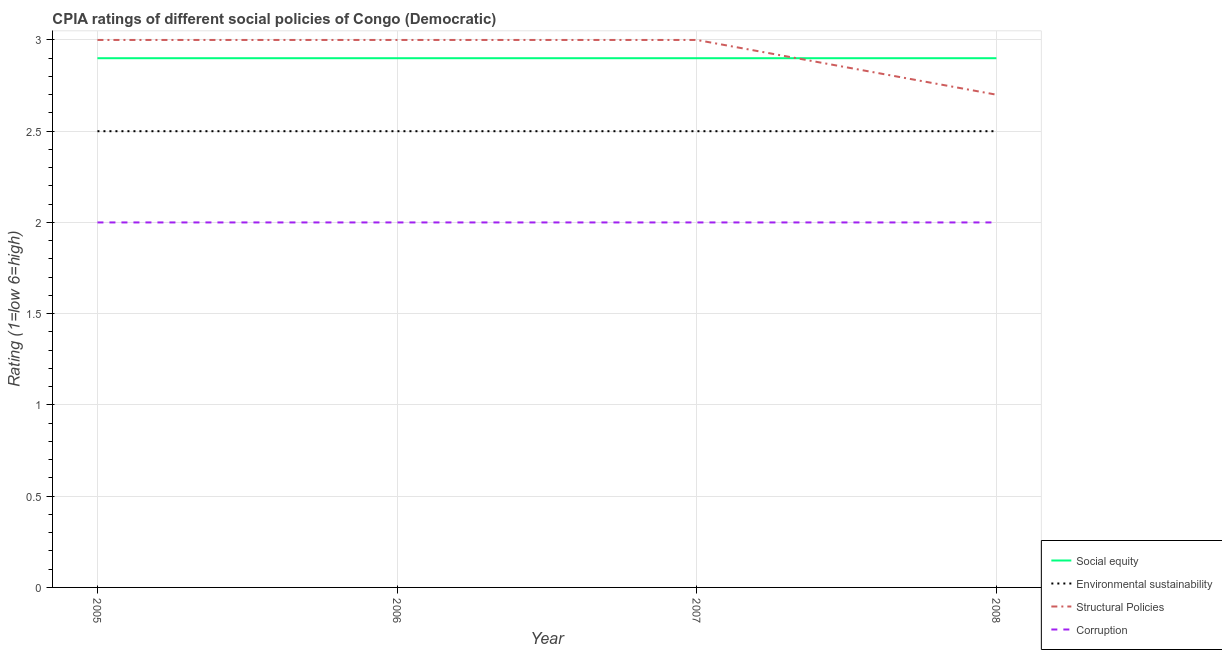What is the cpia rating of corruption in 2008?
Offer a terse response. 2. Across all years, what is the maximum cpia rating of corruption?
Your answer should be compact. 2. Across all years, what is the minimum cpia rating of environmental sustainability?
Provide a succinct answer. 2.5. What is the total cpia rating of social equity in the graph?
Offer a terse response. 11.6. What is the difference between the cpia rating of corruption in 2006 and that in 2007?
Make the answer very short. 0. What is the average cpia rating of structural policies per year?
Offer a very short reply. 2.92. In the year 2007, what is the difference between the cpia rating of corruption and cpia rating of environmental sustainability?
Your answer should be very brief. -0.5. In how many years, is the cpia rating of social equity greater than 1.1?
Your answer should be very brief. 4. Is the cpia rating of corruption in 2005 less than that in 2006?
Keep it short and to the point. No. Is the difference between the cpia rating of environmental sustainability in 2006 and 2008 greater than the difference between the cpia rating of corruption in 2006 and 2008?
Give a very brief answer. No. What is the difference between the highest and the second highest cpia rating of environmental sustainability?
Provide a short and direct response. 0. Is it the case that in every year, the sum of the cpia rating of social equity and cpia rating of environmental sustainability is greater than the cpia rating of structural policies?
Offer a terse response. Yes. Is the cpia rating of structural policies strictly greater than the cpia rating of environmental sustainability over the years?
Your answer should be very brief. Yes. What is the difference between two consecutive major ticks on the Y-axis?
Keep it short and to the point. 0.5. Are the values on the major ticks of Y-axis written in scientific E-notation?
Give a very brief answer. No. Does the graph contain any zero values?
Offer a terse response. No. Does the graph contain grids?
Ensure brevity in your answer.  Yes. What is the title of the graph?
Provide a short and direct response. CPIA ratings of different social policies of Congo (Democratic). Does "Payroll services" appear as one of the legend labels in the graph?
Make the answer very short. No. What is the label or title of the X-axis?
Your answer should be compact. Year. What is the Rating (1=low 6=high) of Social equity in 2007?
Offer a terse response. 2.9. What is the Rating (1=low 6=high) in Environmental sustainability in 2007?
Offer a terse response. 2.5. What is the Rating (1=low 6=high) in Environmental sustainability in 2008?
Make the answer very short. 2.5. What is the Rating (1=low 6=high) of Structural Policies in 2008?
Keep it short and to the point. 2.7. What is the Rating (1=low 6=high) of Corruption in 2008?
Make the answer very short. 2. Across all years, what is the maximum Rating (1=low 6=high) in Social equity?
Provide a succinct answer. 2.9. Across all years, what is the maximum Rating (1=low 6=high) in Structural Policies?
Offer a terse response. 3. Across all years, what is the maximum Rating (1=low 6=high) in Corruption?
Your answer should be compact. 2. Across all years, what is the minimum Rating (1=low 6=high) in Corruption?
Your answer should be compact. 2. What is the total Rating (1=low 6=high) of Environmental sustainability in the graph?
Provide a short and direct response. 10. What is the total Rating (1=low 6=high) in Structural Policies in the graph?
Ensure brevity in your answer.  11.7. What is the total Rating (1=low 6=high) of Corruption in the graph?
Offer a very short reply. 8. What is the difference between the Rating (1=low 6=high) of Social equity in 2005 and that in 2006?
Ensure brevity in your answer.  0. What is the difference between the Rating (1=low 6=high) of Environmental sustainability in 2005 and that in 2006?
Provide a short and direct response. 0. What is the difference between the Rating (1=low 6=high) of Structural Policies in 2005 and that in 2006?
Your response must be concise. 0. What is the difference between the Rating (1=low 6=high) in Social equity in 2005 and that in 2007?
Offer a terse response. 0. What is the difference between the Rating (1=low 6=high) of Structural Policies in 2005 and that in 2007?
Keep it short and to the point. 0. What is the difference between the Rating (1=low 6=high) of Corruption in 2005 and that in 2007?
Offer a very short reply. 0. What is the difference between the Rating (1=low 6=high) in Environmental sustainability in 2005 and that in 2008?
Ensure brevity in your answer.  0. What is the difference between the Rating (1=low 6=high) of Structural Policies in 2005 and that in 2008?
Ensure brevity in your answer.  0.3. What is the difference between the Rating (1=low 6=high) in Social equity in 2006 and that in 2007?
Ensure brevity in your answer.  0. What is the difference between the Rating (1=low 6=high) in Social equity in 2006 and that in 2008?
Provide a short and direct response. 0. What is the difference between the Rating (1=low 6=high) of Social equity in 2007 and that in 2008?
Provide a succinct answer. 0. What is the difference between the Rating (1=low 6=high) in Social equity in 2005 and the Rating (1=low 6=high) in Structural Policies in 2006?
Ensure brevity in your answer.  -0.1. What is the difference between the Rating (1=low 6=high) of Social equity in 2005 and the Rating (1=low 6=high) of Corruption in 2006?
Provide a succinct answer. 0.9. What is the difference between the Rating (1=low 6=high) in Structural Policies in 2005 and the Rating (1=low 6=high) in Corruption in 2006?
Provide a succinct answer. 1. What is the difference between the Rating (1=low 6=high) in Social equity in 2005 and the Rating (1=low 6=high) in Corruption in 2007?
Ensure brevity in your answer.  0.9. What is the difference between the Rating (1=low 6=high) in Environmental sustainability in 2005 and the Rating (1=low 6=high) in Structural Policies in 2007?
Offer a very short reply. -0.5. What is the difference between the Rating (1=low 6=high) of Environmental sustainability in 2005 and the Rating (1=low 6=high) of Corruption in 2007?
Ensure brevity in your answer.  0.5. What is the difference between the Rating (1=low 6=high) of Structural Policies in 2005 and the Rating (1=low 6=high) of Corruption in 2007?
Offer a terse response. 1. What is the difference between the Rating (1=low 6=high) of Social equity in 2005 and the Rating (1=low 6=high) of Structural Policies in 2008?
Your response must be concise. 0.2. What is the difference between the Rating (1=low 6=high) in Environmental sustainability in 2005 and the Rating (1=low 6=high) in Corruption in 2008?
Your answer should be very brief. 0.5. What is the difference between the Rating (1=low 6=high) in Structural Policies in 2005 and the Rating (1=low 6=high) in Corruption in 2008?
Keep it short and to the point. 1. What is the difference between the Rating (1=low 6=high) of Social equity in 2006 and the Rating (1=low 6=high) of Corruption in 2007?
Provide a succinct answer. 0.9. What is the difference between the Rating (1=low 6=high) in Environmental sustainability in 2006 and the Rating (1=low 6=high) in Structural Policies in 2007?
Your answer should be very brief. -0.5. What is the difference between the Rating (1=low 6=high) of Structural Policies in 2006 and the Rating (1=low 6=high) of Corruption in 2007?
Make the answer very short. 1. What is the difference between the Rating (1=low 6=high) of Social equity in 2006 and the Rating (1=low 6=high) of Environmental sustainability in 2008?
Offer a terse response. 0.4. What is the difference between the Rating (1=low 6=high) in Social equity in 2006 and the Rating (1=low 6=high) in Corruption in 2008?
Give a very brief answer. 0.9. What is the difference between the Rating (1=low 6=high) of Environmental sustainability in 2006 and the Rating (1=low 6=high) of Structural Policies in 2008?
Offer a very short reply. -0.2. What is the difference between the Rating (1=low 6=high) in Environmental sustainability in 2006 and the Rating (1=low 6=high) in Corruption in 2008?
Keep it short and to the point. 0.5. What is the difference between the Rating (1=low 6=high) in Social equity in 2007 and the Rating (1=low 6=high) in Environmental sustainability in 2008?
Offer a very short reply. 0.4. What is the difference between the Rating (1=low 6=high) in Social equity in 2007 and the Rating (1=low 6=high) in Corruption in 2008?
Provide a short and direct response. 0.9. What is the difference between the Rating (1=low 6=high) in Environmental sustainability in 2007 and the Rating (1=low 6=high) in Structural Policies in 2008?
Keep it short and to the point. -0.2. What is the difference between the Rating (1=low 6=high) of Environmental sustainability in 2007 and the Rating (1=low 6=high) of Corruption in 2008?
Offer a terse response. 0.5. What is the difference between the Rating (1=low 6=high) of Structural Policies in 2007 and the Rating (1=low 6=high) of Corruption in 2008?
Give a very brief answer. 1. What is the average Rating (1=low 6=high) of Social equity per year?
Give a very brief answer. 2.9. What is the average Rating (1=low 6=high) in Structural Policies per year?
Your answer should be very brief. 2.92. In the year 2005, what is the difference between the Rating (1=low 6=high) of Social equity and Rating (1=low 6=high) of Corruption?
Your answer should be compact. 0.9. In the year 2005, what is the difference between the Rating (1=low 6=high) in Environmental sustainability and Rating (1=low 6=high) in Structural Policies?
Your response must be concise. -0.5. In the year 2005, what is the difference between the Rating (1=low 6=high) of Environmental sustainability and Rating (1=low 6=high) of Corruption?
Offer a very short reply. 0.5. In the year 2005, what is the difference between the Rating (1=low 6=high) of Structural Policies and Rating (1=low 6=high) of Corruption?
Your answer should be very brief. 1. In the year 2006, what is the difference between the Rating (1=low 6=high) in Social equity and Rating (1=low 6=high) in Environmental sustainability?
Offer a very short reply. 0.4. In the year 2006, what is the difference between the Rating (1=low 6=high) in Environmental sustainability and Rating (1=low 6=high) in Corruption?
Make the answer very short. 0.5. In the year 2006, what is the difference between the Rating (1=low 6=high) in Structural Policies and Rating (1=low 6=high) in Corruption?
Your answer should be very brief. 1. In the year 2007, what is the difference between the Rating (1=low 6=high) in Social equity and Rating (1=low 6=high) in Environmental sustainability?
Ensure brevity in your answer.  0.4. In the year 2007, what is the difference between the Rating (1=low 6=high) in Social equity and Rating (1=low 6=high) in Structural Policies?
Provide a short and direct response. -0.1. In the year 2007, what is the difference between the Rating (1=low 6=high) of Social equity and Rating (1=low 6=high) of Corruption?
Offer a terse response. 0.9. In the year 2007, what is the difference between the Rating (1=low 6=high) of Environmental sustainability and Rating (1=low 6=high) of Corruption?
Provide a short and direct response. 0.5. In the year 2007, what is the difference between the Rating (1=low 6=high) in Structural Policies and Rating (1=low 6=high) in Corruption?
Offer a very short reply. 1. In the year 2008, what is the difference between the Rating (1=low 6=high) in Social equity and Rating (1=low 6=high) in Environmental sustainability?
Your answer should be very brief. 0.4. In the year 2008, what is the difference between the Rating (1=low 6=high) in Social equity and Rating (1=low 6=high) in Structural Policies?
Your answer should be compact. 0.2. What is the ratio of the Rating (1=low 6=high) of Structural Policies in 2005 to that in 2006?
Your response must be concise. 1. What is the ratio of the Rating (1=low 6=high) of Corruption in 2005 to that in 2007?
Provide a short and direct response. 1. What is the ratio of the Rating (1=low 6=high) of Social equity in 2005 to that in 2008?
Make the answer very short. 1. What is the ratio of the Rating (1=low 6=high) of Environmental sustainability in 2006 to that in 2007?
Ensure brevity in your answer.  1. What is the ratio of the Rating (1=low 6=high) of Structural Policies in 2006 to that in 2007?
Your answer should be compact. 1. What is the ratio of the Rating (1=low 6=high) in Corruption in 2006 to that in 2007?
Provide a short and direct response. 1. What is the ratio of the Rating (1=low 6=high) of Social equity in 2006 to that in 2008?
Ensure brevity in your answer.  1. What is the ratio of the Rating (1=low 6=high) of Social equity in 2007 to that in 2008?
Your response must be concise. 1. What is the ratio of the Rating (1=low 6=high) of Structural Policies in 2007 to that in 2008?
Your response must be concise. 1.11. What is the ratio of the Rating (1=low 6=high) of Corruption in 2007 to that in 2008?
Make the answer very short. 1. What is the difference between the highest and the second highest Rating (1=low 6=high) of Corruption?
Provide a short and direct response. 0. What is the difference between the highest and the lowest Rating (1=low 6=high) of Social equity?
Make the answer very short. 0. What is the difference between the highest and the lowest Rating (1=low 6=high) in Structural Policies?
Provide a short and direct response. 0.3. What is the difference between the highest and the lowest Rating (1=low 6=high) in Corruption?
Provide a short and direct response. 0. 